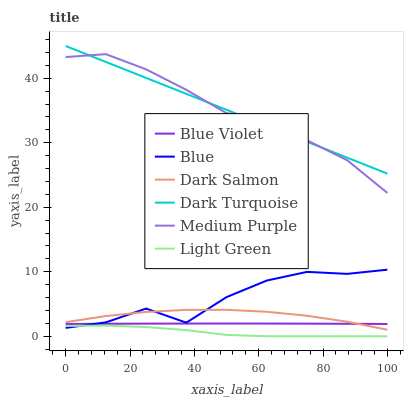Does Light Green have the minimum area under the curve?
Answer yes or no. Yes. Does Medium Purple have the maximum area under the curve?
Answer yes or no. Yes. Does Dark Turquoise have the minimum area under the curve?
Answer yes or no. No. Does Dark Turquoise have the maximum area under the curve?
Answer yes or no. No. Is Dark Turquoise the smoothest?
Answer yes or no. Yes. Is Blue the roughest?
Answer yes or no. Yes. Is Dark Salmon the smoothest?
Answer yes or no. No. Is Dark Salmon the roughest?
Answer yes or no. No. Does Light Green have the lowest value?
Answer yes or no. Yes. Does Dark Salmon have the lowest value?
Answer yes or no. No. Does Dark Turquoise have the highest value?
Answer yes or no. Yes. Does Dark Salmon have the highest value?
Answer yes or no. No. Is Blue less than Medium Purple?
Answer yes or no. Yes. Is Dark Turquoise greater than Blue?
Answer yes or no. Yes. Does Dark Salmon intersect Blue?
Answer yes or no. Yes. Is Dark Salmon less than Blue?
Answer yes or no. No. Is Dark Salmon greater than Blue?
Answer yes or no. No. Does Blue intersect Medium Purple?
Answer yes or no. No. 